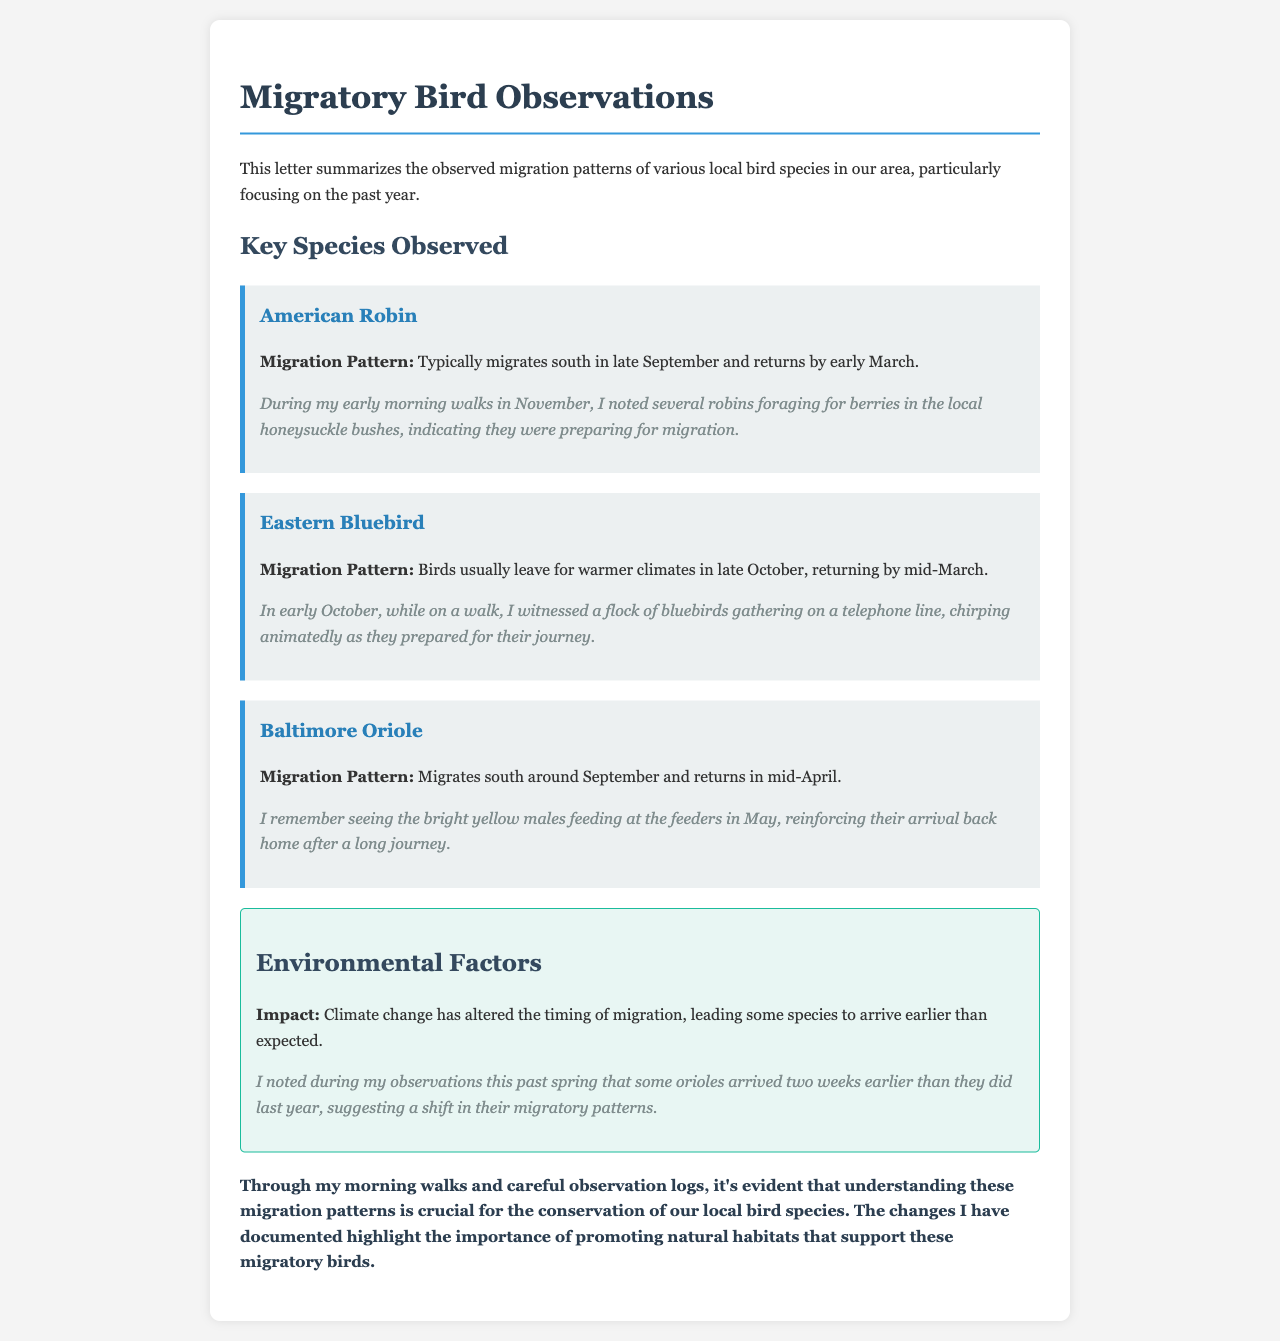What species migrates south in late September? The American Robin typically migrates south in late September.
Answer: American Robin When do Eastern Bluebirds return? Eastern Bluebirds usually return by mid-March.
Answer: Mid-March What was observed about the orioles' arrival timing? The document notes that some orioles arrived two weeks earlier than they did last year.
Answer: Two weeks earlier Which environmental factor is mentioned as affecting migration? Climate change is mentioned as impacting the timing of migration.
Answer: Climate change What personal anecdote is shared about the bluebirds? The author witnessed a flock of bluebirds gathering on a telephone line in early October.
Answer: Gathering on a telephone line What does the conclusion emphasize? The conclusion emphasizes the importance of understanding migration patterns for conservation.
Answer: Conservation of local bird species 